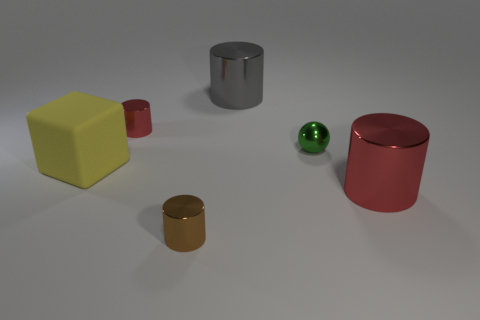Add 1 yellow blocks. How many objects exist? 7 Subtract all balls. How many objects are left? 5 Subtract 0 cyan cubes. How many objects are left? 6 Subtract all matte things. Subtract all small brown objects. How many objects are left? 4 Add 3 large yellow cubes. How many large yellow cubes are left? 4 Add 5 tiny blue matte cubes. How many tiny blue matte cubes exist? 5 